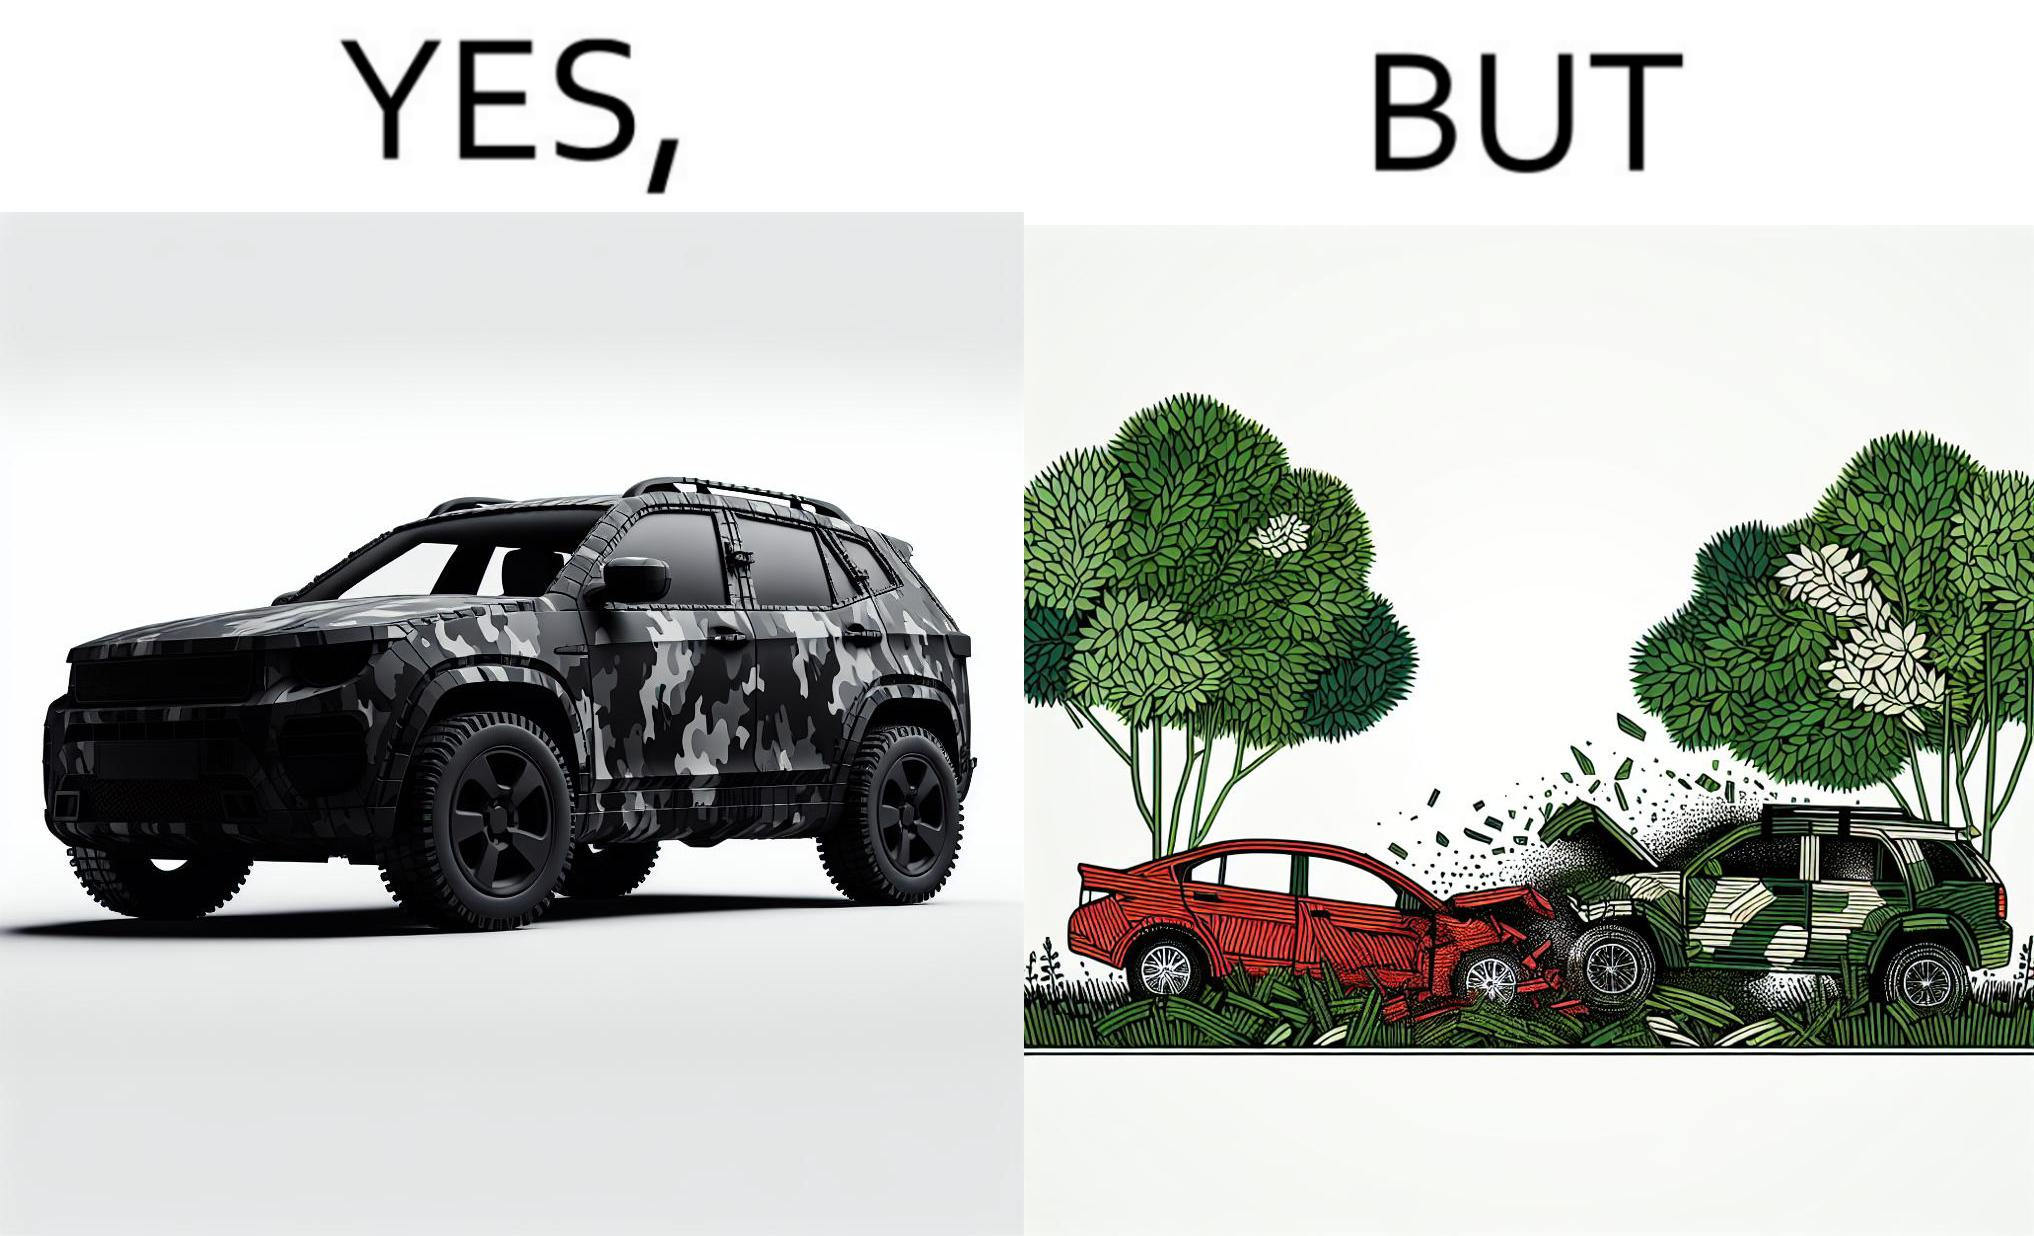Is this a satirical image? Yes, this image is satirical. 